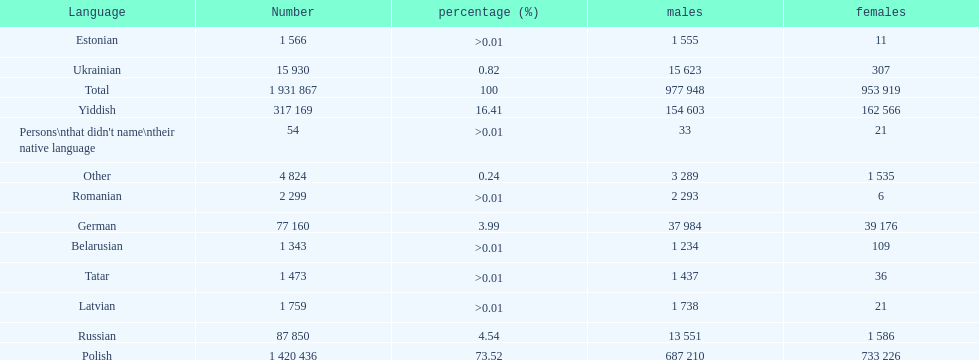What was the next most commonly spoken language in poland after russian? German. 